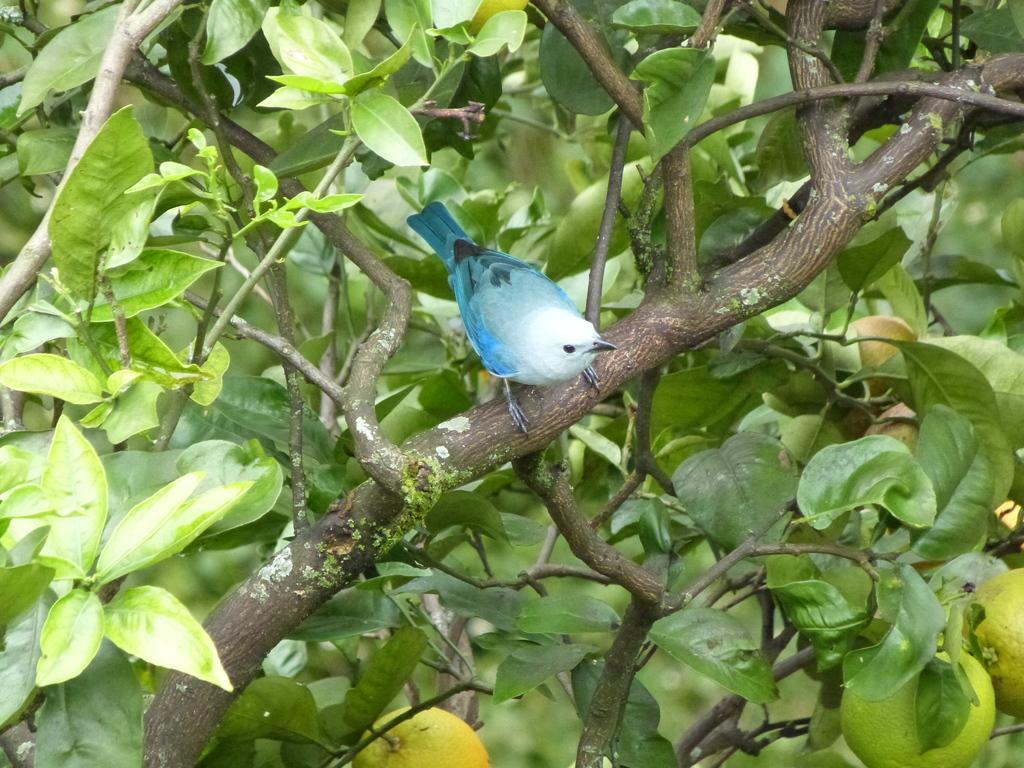How would you summarize this image in a sentence or two? In the image there is a blue color bird standing on branch of a tree. 